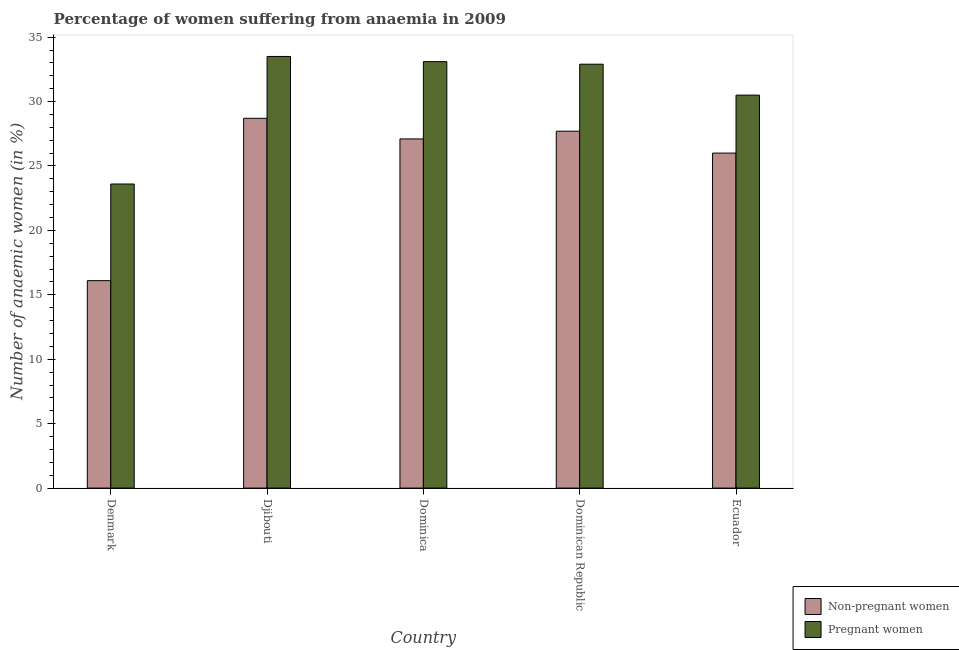What is the label of the 2nd group of bars from the left?
Make the answer very short. Djibouti. In how many cases, is the number of bars for a given country not equal to the number of legend labels?
Offer a terse response. 0. What is the percentage of pregnant anaemic women in Dominican Republic?
Your response must be concise. 32.9. Across all countries, what is the maximum percentage of non-pregnant anaemic women?
Make the answer very short. 28.7. In which country was the percentage of non-pregnant anaemic women maximum?
Offer a very short reply. Djibouti. In which country was the percentage of non-pregnant anaemic women minimum?
Your response must be concise. Denmark. What is the total percentage of non-pregnant anaemic women in the graph?
Give a very brief answer. 125.6. What is the difference between the percentage of non-pregnant anaemic women in Denmark and that in Ecuador?
Your answer should be very brief. -9.9. What is the average percentage of non-pregnant anaemic women per country?
Offer a terse response. 25.12. What is the difference between the percentage of pregnant anaemic women and percentage of non-pregnant anaemic women in Ecuador?
Your answer should be compact. 4.5. In how many countries, is the percentage of pregnant anaemic women greater than 22 %?
Offer a very short reply. 5. What is the ratio of the percentage of pregnant anaemic women in Djibouti to that in Ecuador?
Make the answer very short. 1.1. What is the difference between the highest and the second highest percentage of pregnant anaemic women?
Offer a very short reply. 0.4. What is the difference between the highest and the lowest percentage of non-pregnant anaemic women?
Keep it short and to the point. 12.6. What does the 1st bar from the left in Dominica represents?
Provide a short and direct response. Non-pregnant women. What does the 1st bar from the right in Dominica represents?
Provide a succinct answer. Pregnant women. How many bars are there?
Give a very brief answer. 10. Are the values on the major ticks of Y-axis written in scientific E-notation?
Provide a succinct answer. No. Does the graph contain any zero values?
Your response must be concise. No. Does the graph contain grids?
Your answer should be compact. No. Where does the legend appear in the graph?
Provide a short and direct response. Bottom right. What is the title of the graph?
Offer a very short reply. Percentage of women suffering from anaemia in 2009. Does "Female population" appear as one of the legend labels in the graph?
Your answer should be compact. No. What is the label or title of the Y-axis?
Offer a terse response. Number of anaemic women (in %). What is the Number of anaemic women (in %) of Pregnant women in Denmark?
Provide a short and direct response. 23.6. What is the Number of anaemic women (in %) in Non-pregnant women in Djibouti?
Make the answer very short. 28.7. What is the Number of anaemic women (in %) in Pregnant women in Djibouti?
Your response must be concise. 33.5. What is the Number of anaemic women (in %) of Non-pregnant women in Dominica?
Your answer should be very brief. 27.1. What is the Number of anaemic women (in %) in Pregnant women in Dominica?
Offer a very short reply. 33.1. What is the Number of anaemic women (in %) in Non-pregnant women in Dominican Republic?
Provide a short and direct response. 27.7. What is the Number of anaemic women (in %) of Pregnant women in Dominican Republic?
Offer a terse response. 32.9. What is the Number of anaemic women (in %) of Pregnant women in Ecuador?
Provide a short and direct response. 30.5. Across all countries, what is the maximum Number of anaemic women (in %) of Non-pregnant women?
Provide a succinct answer. 28.7. Across all countries, what is the maximum Number of anaemic women (in %) of Pregnant women?
Ensure brevity in your answer.  33.5. Across all countries, what is the minimum Number of anaemic women (in %) in Non-pregnant women?
Ensure brevity in your answer.  16.1. Across all countries, what is the minimum Number of anaemic women (in %) of Pregnant women?
Make the answer very short. 23.6. What is the total Number of anaemic women (in %) of Non-pregnant women in the graph?
Provide a succinct answer. 125.6. What is the total Number of anaemic women (in %) in Pregnant women in the graph?
Offer a very short reply. 153.6. What is the difference between the Number of anaemic women (in %) of Non-pregnant women in Denmark and that in Dominica?
Your answer should be compact. -11. What is the difference between the Number of anaemic women (in %) of Pregnant women in Denmark and that in Dominica?
Make the answer very short. -9.5. What is the difference between the Number of anaemic women (in %) in Pregnant women in Denmark and that in Dominican Republic?
Ensure brevity in your answer.  -9.3. What is the difference between the Number of anaemic women (in %) of Non-pregnant women in Denmark and that in Ecuador?
Offer a terse response. -9.9. What is the difference between the Number of anaemic women (in %) in Pregnant women in Denmark and that in Ecuador?
Make the answer very short. -6.9. What is the difference between the Number of anaemic women (in %) of Pregnant women in Djibouti and that in Dominica?
Offer a terse response. 0.4. What is the difference between the Number of anaemic women (in %) in Non-pregnant women in Djibouti and that in Ecuador?
Keep it short and to the point. 2.7. What is the difference between the Number of anaemic women (in %) in Pregnant women in Djibouti and that in Ecuador?
Your response must be concise. 3. What is the difference between the Number of anaemic women (in %) of Pregnant women in Dominica and that in Dominican Republic?
Keep it short and to the point. 0.2. What is the difference between the Number of anaemic women (in %) in Non-pregnant women in Denmark and the Number of anaemic women (in %) in Pregnant women in Djibouti?
Your answer should be compact. -17.4. What is the difference between the Number of anaemic women (in %) of Non-pregnant women in Denmark and the Number of anaemic women (in %) of Pregnant women in Dominican Republic?
Offer a terse response. -16.8. What is the difference between the Number of anaemic women (in %) of Non-pregnant women in Denmark and the Number of anaemic women (in %) of Pregnant women in Ecuador?
Give a very brief answer. -14.4. What is the difference between the Number of anaemic women (in %) in Non-pregnant women in Djibouti and the Number of anaemic women (in %) in Pregnant women in Dominica?
Make the answer very short. -4.4. What is the difference between the Number of anaemic women (in %) of Non-pregnant women in Djibouti and the Number of anaemic women (in %) of Pregnant women in Dominican Republic?
Provide a succinct answer. -4.2. What is the difference between the Number of anaemic women (in %) of Non-pregnant women in Dominica and the Number of anaemic women (in %) of Pregnant women in Dominican Republic?
Your answer should be very brief. -5.8. What is the average Number of anaemic women (in %) in Non-pregnant women per country?
Your answer should be very brief. 25.12. What is the average Number of anaemic women (in %) of Pregnant women per country?
Offer a terse response. 30.72. What is the difference between the Number of anaemic women (in %) of Non-pregnant women and Number of anaemic women (in %) of Pregnant women in Denmark?
Give a very brief answer. -7.5. What is the difference between the Number of anaemic women (in %) in Non-pregnant women and Number of anaemic women (in %) in Pregnant women in Dominican Republic?
Provide a short and direct response. -5.2. What is the ratio of the Number of anaemic women (in %) of Non-pregnant women in Denmark to that in Djibouti?
Give a very brief answer. 0.56. What is the ratio of the Number of anaemic women (in %) of Pregnant women in Denmark to that in Djibouti?
Provide a succinct answer. 0.7. What is the ratio of the Number of anaemic women (in %) in Non-pregnant women in Denmark to that in Dominica?
Make the answer very short. 0.59. What is the ratio of the Number of anaemic women (in %) in Pregnant women in Denmark to that in Dominica?
Offer a very short reply. 0.71. What is the ratio of the Number of anaemic women (in %) in Non-pregnant women in Denmark to that in Dominican Republic?
Your response must be concise. 0.58. What is the ratio of the Number of anaemic women (in %) in Pregnant women in Denmark to that in Dominican Republic?
Offer a very short reply. 0.72. What is the ratio of the Number of anaemic women (in %) in Non-pregnant women in Denmark to that in Ecuador?
Ensure brevity in your answer.  0.62. What is the ratio of the Number of anaemic women (in %) of Pregnant women in Denmark to that in Ecuador?
Make the answer very short. 0.77. What is the ratio of the Number of anaemic women (in %) in Non-pregnant women in Djibouti to that in Dominica?
Your response must be concise. 1.06. What is the ratio of the Number of anaemic women (in %) in Pregnant women in Djibouti to that in Dominica?
Make the answer very short. 1.01. What is the ratio of the Number of anaemic women (in %) in Non-pregnant women in Djibouti to that in Dominican Republic?
Your answer should be very brief. 1.04. What is the ratio of the Number of anaemic women (in %) of Pregnant women in Djibouti to that in Dominican Republic?
Offer a very short reply. 1.02. What is the ratio of the Number of anaemic women (in %) of Non-pregnant women in Djibouti to that in Ecuador?
Keep it short and to the point. 1.1. What is the ratio of the Number of anaemic women (in %) in Pregnant women in Djibouti to that in Ecuador?
Keep it short and to the point. 1.1. What is the ratio of the Number of anaemic women (in %) of Non-pregnant women in Dominica to that in Dominican Republic?
Your response must be concise. 0.98. What is the ratio of the Number of anaemic women (in %) of Pregnant women in Dominica to that in Dominican Republic?
Your answer should be compact. 1.01. What is the ratio of the Number of anaemic women (in %) in Non-pregnant women in Dominica to that in Ecuador?
Make the answer very short. 1.04. What is the ratio of the Number of anaemic women (in %) of Pregnant women in Dominica to that in Ecuador?
Your response must be concise. 1.09. What is the ratio of the Number of anaemic women (in %) of Non-pregnant women in Dominican Republic to that in Ecuador?
Give a very brief answer. 1.07. What is the ratio of the Number of anaemic women (in %) of Pregnant women in Dominican Republic to that in Ecuador?
Keep it short and to the point. 1.08. What is the difference between the highest and the second highest Number of anaemic women (in %) in Pregnant women?
Keep it short and to the point. 0.4. 